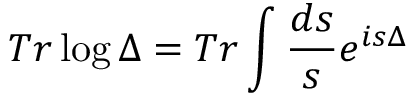<formula> <loc_0><loc_0><loc_500><loc_500>T r \log \Delta = T r \int \frac { d s } { s } e ^ { i s \Delta }</formula> 